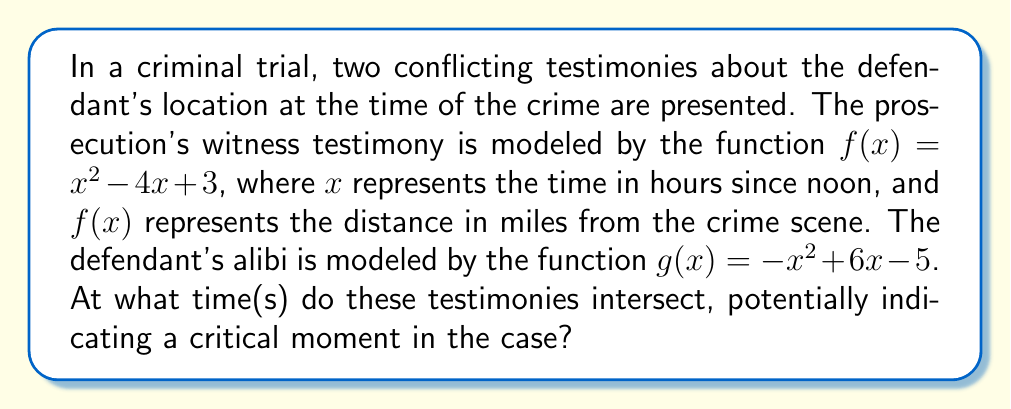Teach me how to tackle this problem. To find the intersection points of the two polynomial functions, we need to solve the equation $f(x) = g(x)$:

1) Set up the equation:
   $x^2 - 4x + 3 = -x^2 + 6x - 5$

2) Rearrange the equation to standard form:
   $x^2 - 4x + 3 + x^2 - 6x + 5 = 0$
   $2x^2 - 10x + 8 = 0$

3) Divide all terms by 2 to simplify:
   $x^2 - 5x + 4 = 0$

4) This is a quadratic equation. We can solve it using the quadratic formula:
   $x = \frac{-b \pm \sqrt{b^2 - 4ac}}{2a}$

   Where $a = 1$, $b = -5$, and $c = 4$

5) Substitute these values into the quadratic formula:
   $x = \frac{5 \pm \sqrt{(-5)^2 - 4(1)(4)}}{2(1)}$
   $x = \frac{5 \pm \sqrt{25 - 16}}{2}$
   $x = \frac{5 \pm \sqrt{9}}{2}$
   $x = \frac{5 \pm 3}{2}$

6) This gives us two solutions:
   $x_1 = \frac{5 + 3}{2} = 4$
   $x_2 = \frac{5 - 3}{2} = 1$

These x-values represent the times (in hours since noon) when the two testimonies intersect.
Answer: The testimonies intersect at 1:00 PM and 4:00 PM. 